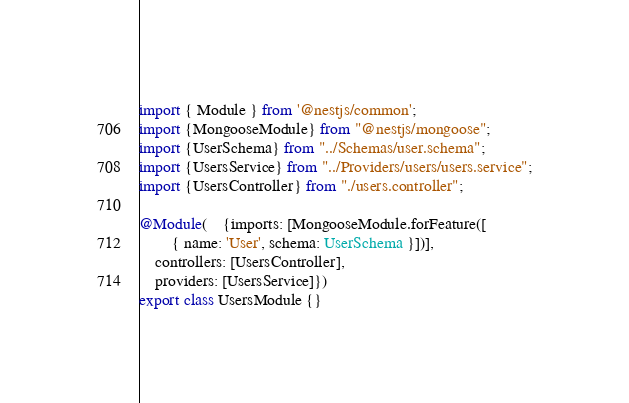Convert code to text. <code><loc_0><loc_0><loc_500><loc_500><_TypeScript_>import { Module } from '@nestjs/common';
import {MongooseModule} from "@nestjs/mongoose";
import {UserSchema} from "../Schemas/user.schema";
import {UsersService} from "../Providers/users/users.service";
import {UsersController} from "./users.controller";

@Module(    {imports: [MongooseModule.forFeature([
        { name: 'User', schema: UserSchema }])],
    controllers: [UsersController],
    providers: [UsersService]})
export class UsersModule {}
</code> 